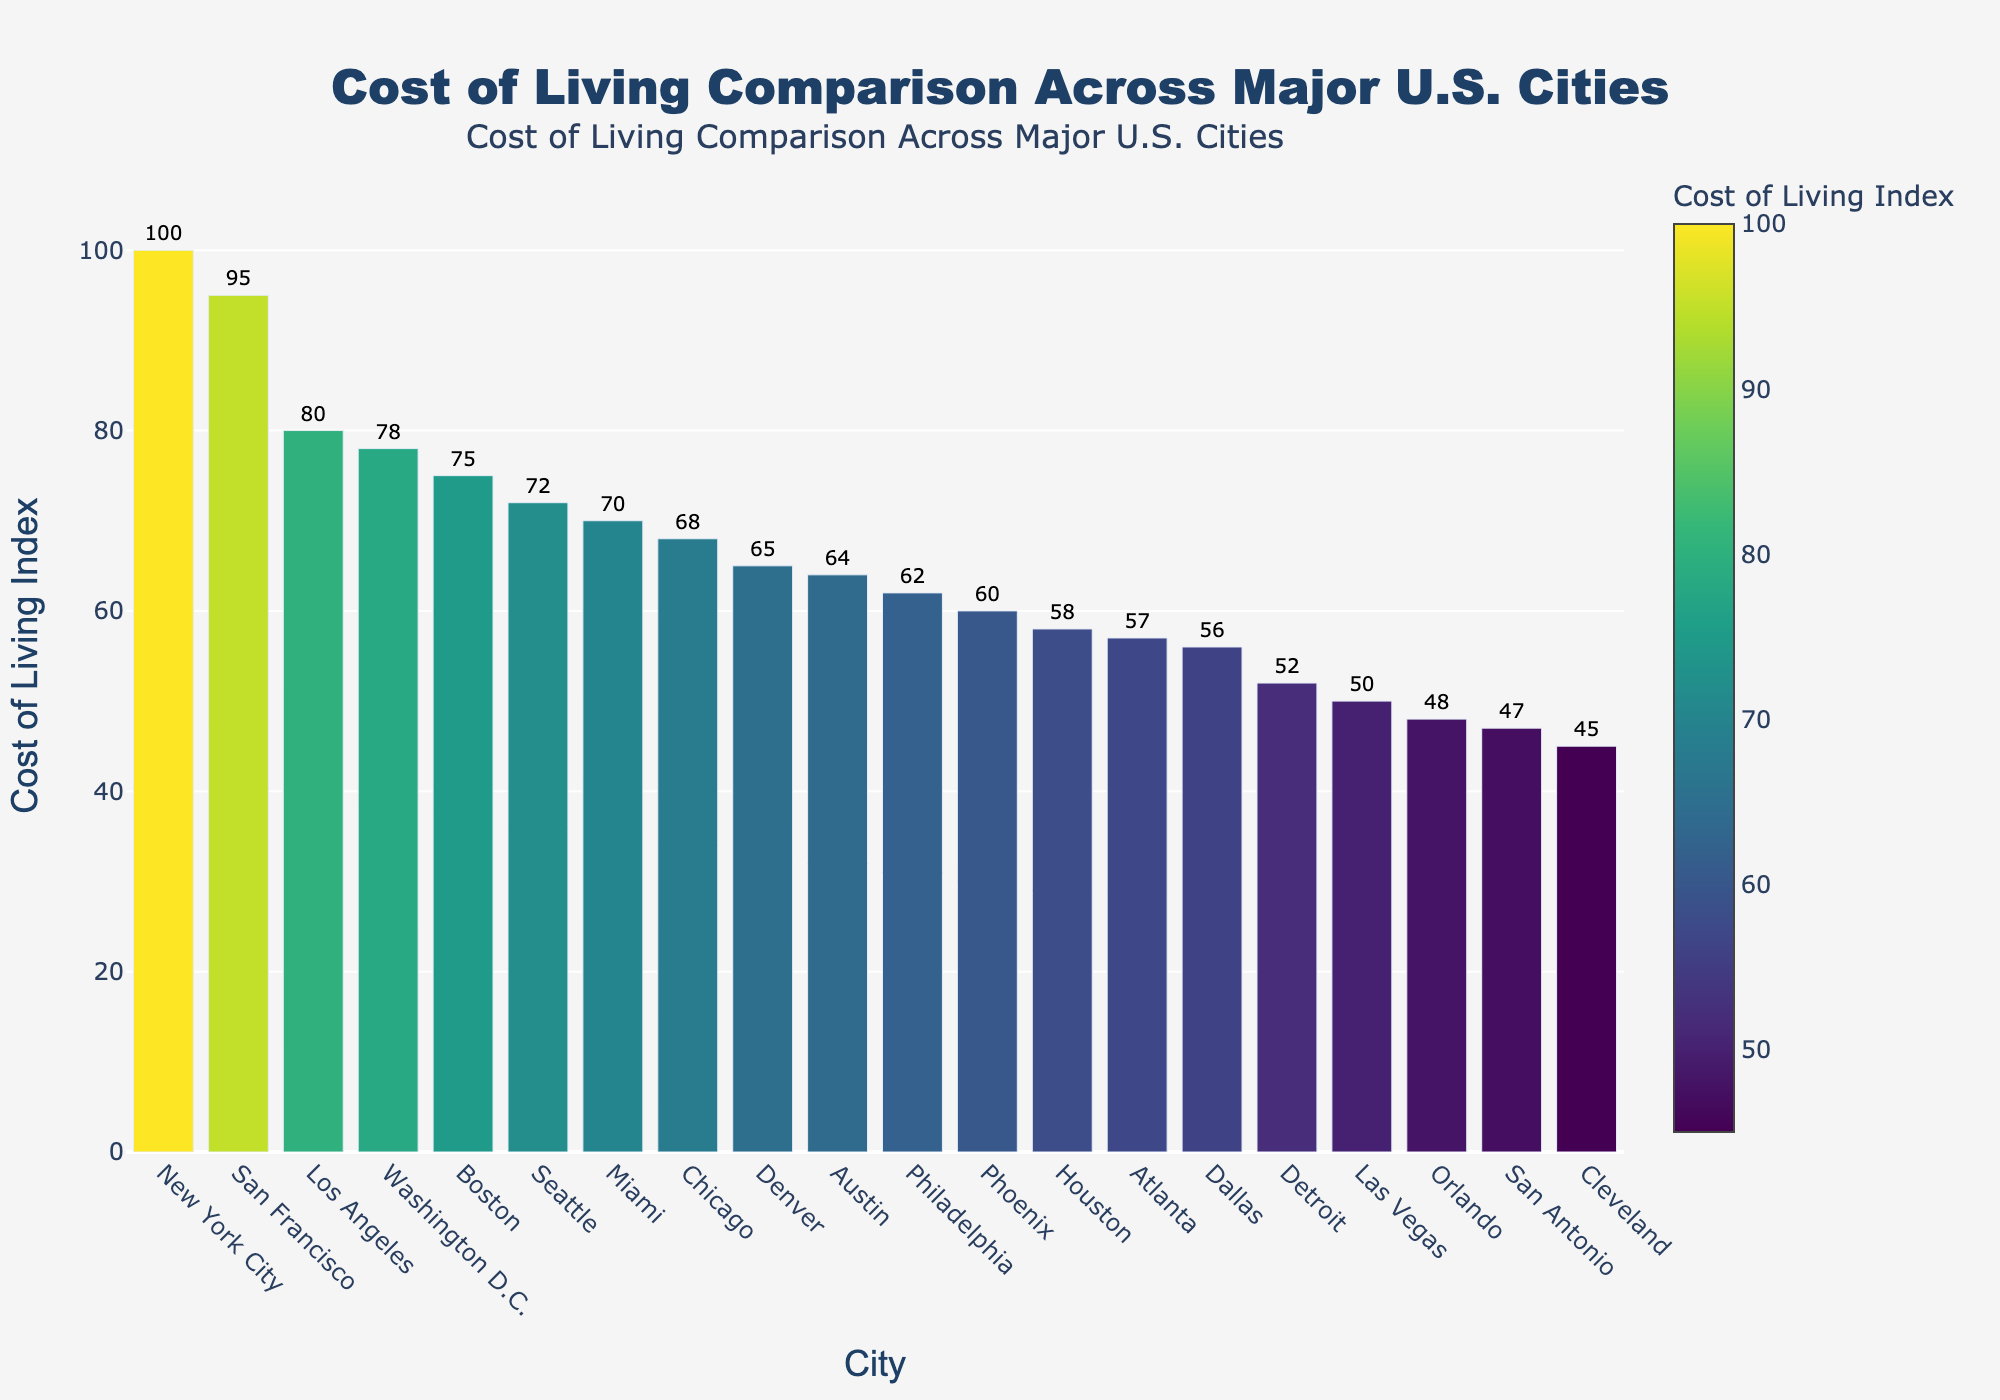What city has the highest cost of living index, and what is the value? The highest bar corresponds to New York City, which has a cost of living index of 100, as indicated by the height and the value displayed.
Answer: New York City, 100 What city has the lowest cost of living index, and what is the value? The shortest bar corresponds to Cleveland, which has a cost of living index of 45, as indicated by the height and the value displayed.
Answer: Cleveland, 45 How much higher is the cost of living index in San Francisco compared to Dallas? The bar for San Francisco shows a cost of living index of 95, while Dallas shows 56. Subtracting these values gives the difference: 95 - 56 = 39.
Answer: 39 Which cities have a cost of living index greater than 70? Observing the bars that exceed the 70 mark on the y-axis, we find New York City, San Francisco, Los Angeles, Washington D.C., Boston, Seattle, and Miami.
Answer: New York City, San Francisco, Los Angeles, Washington D.C., Boston, Seattle, Miami What is the combined cost of living index for Phoenix, Houston, and Atlanta? Adding the cost of living indices for the three cities: Phoenix (60) + Houston (58) + Atlanta (57) = 175.
Answer: 175 How does the cost of living index in Chicago compare to that in Philadelphia? The bar for Chicago shows a cost of living index of 68, while Philadelphia shows 62. Since 68 is greater than 62, Chicago has a higher cost of living index.
Answer: Chicago is higher What are the cities with a cost of living index under 50? Observing the bars that do not reach the 50 mark on the y-axis, we find Cleveland (45), Orlando (48), and San Antonio (47).
Answer: Cleveland, Orlando, San Antonio What is the difference in the cost of living index between Austin and Denver? The bar for Austin shows a cost of living index of 64, while Denver shows 65. The difference is: 65 - 64 = 1.
Answer: 1 